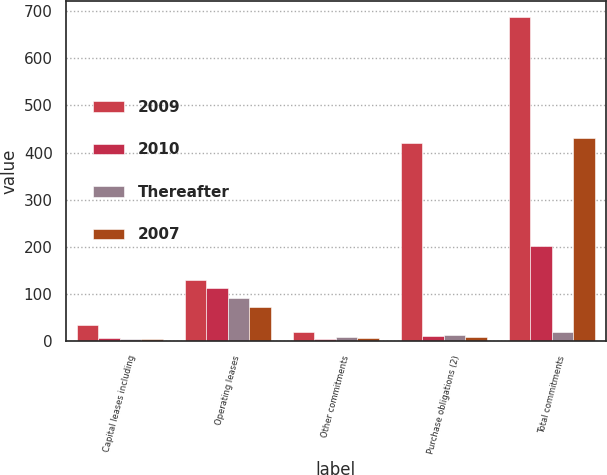Convert chart to OTSL. <chart><loc_0><loc_0><loc_500><loc_500><stacked_bar_chart><ecel><fcel>Capital leases including<fcel>Operating leases<fcel>Other commitments<fcel>Purchase obligations (2)<fcel>Total commitments<nl><fcel>2009<fcel>35<fcel>129<fcel>20<fcel>420<fcel>687<nl><fcel>2010<fcel>7<fcel>113<fcel>5<fcel>11<fcel>202<nl><fcel>Thereafter<fcel>5<fcel>91<fcel>8<fcel>12<fcel>20<nl><fcel>2007<fcel>4<fcel>72<fcel>6<fcel>9<fcel>430<nl></chart> 